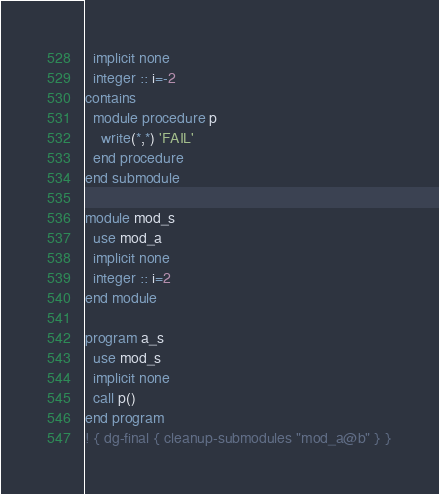<code> <loc_0><loc_0><loc_500><loc_500><_FORTRAN_>  implicit none
  integer :: i=-2
contains
  module procedure p
    write(*,*) 'FAIL'
  end procedure
end submodule

module mod_s
  use mod_a
  implicit none
  integer :: i=2
end module

program a_s
  use mod_s
  implicit none
  call p()
end program
! { dg-final { cleanup-submodules "mod_a@b" } }
</code> 